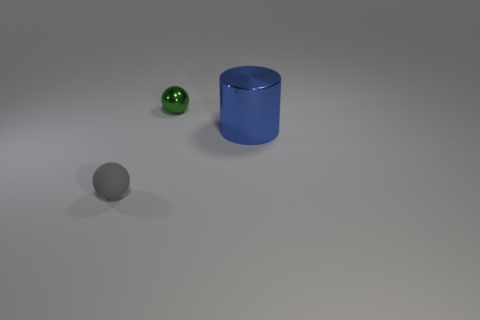Is there any other thing that has the same material as the tiny gray thing?
Your response must be concise. No. What number of objects are either balls behind the large blue metallic object or big green metallic objects?
Offer a very short reply. 1. Is there a gray rubber thing that is behind the small sphere to the right of the small sphere that is in front of the small green ball?
Make the answer very short. No. What number of big purple metal blocks are there?
Offer a terse response. 0. What number of things are tiny balls that are behind the tiny gray rubber sphere or small balls that are on the left side of the small green object?
Your response must be concise. 2. There is a sphere that is in front of the blue metallic thing; is it the same size as the big blue cylinder?
Provide a short and direct response. No. What is the size of the green metallic thing that is the same shape as the gray matte object?
Your response must be concise. Small. There is a object that is the same size as the rubber ball; what material is it?
Ensure brevity in your answer.  Metal. There is a small green thing that is the same shape as the gray matte object; what is it made of?
Ensure brevity in your answer.  Metal. What number of other objects are the same size as the green thing?
Offer a terse response. 1. 